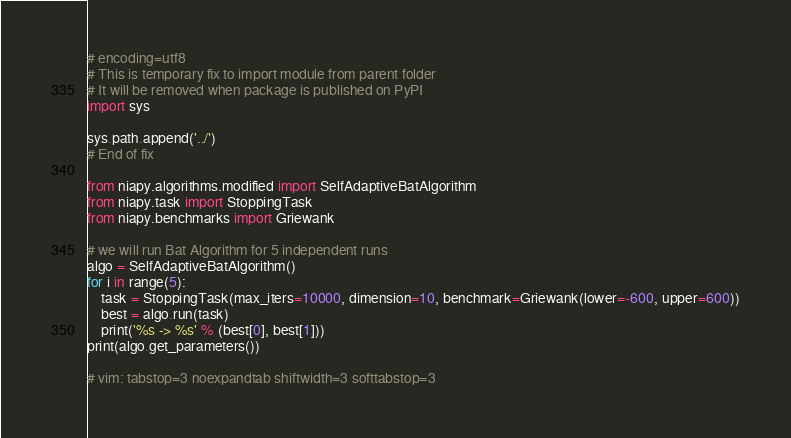<code> <loc_0><loc_0><loc_500><loc_500><_Python_># encoding=utf8
# This is temporary fix to import module from parent folder
# It will be removed when package is published on PyPI
import sys

sys.path.append('../')
# End of fix

from niapy.algorithms.modified import SelfAdaptiveBatAlgorithm
from niapy.task import StoppingTask
from niapy.benchmarks import Griewank

# we will run Bat Algorithm for 5 independent runs
algo = SelfAdaptiveBatAlgorithm()
for i in range(5):
    task = StoppingTask(max_iters=10000, dimension=10, benchmark=Griewank(lower=-600, upper=600))
    best = algo.run(task)
    print('%s -> %s' % (best[0], best[1]))
print(algo.get_parameters())

# vim: tabstop=3 noexpandtab shiftwidth=3 softtabstop=3
</code> 